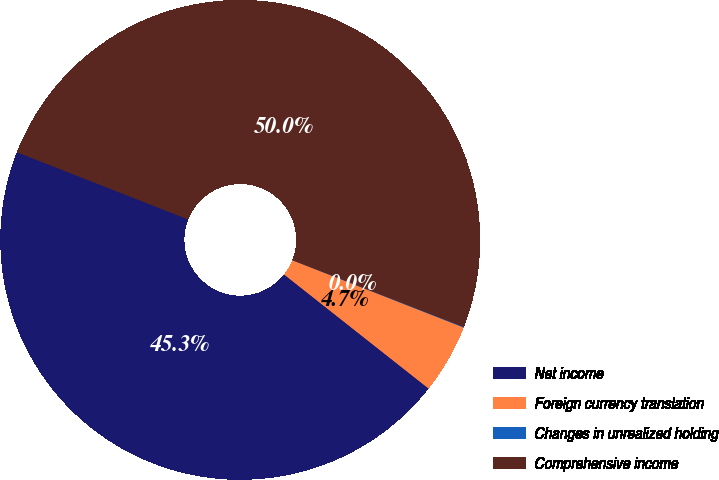<chart> <loc_0><loc_0><loc_500><loc_500><pie_chart><fcel>Net income<fcel>Foreign currency translation<fcel>Changes in unrealized holding<fcel>Comprehensive income<nl><fcel>45.32%<fcel>4.68%<fcel>0.04%<fcel>49.96%<nl></chart> 